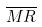<formula> <loc_0><loc_0><loc_500><loc_500>\overline { M R }</formula> 